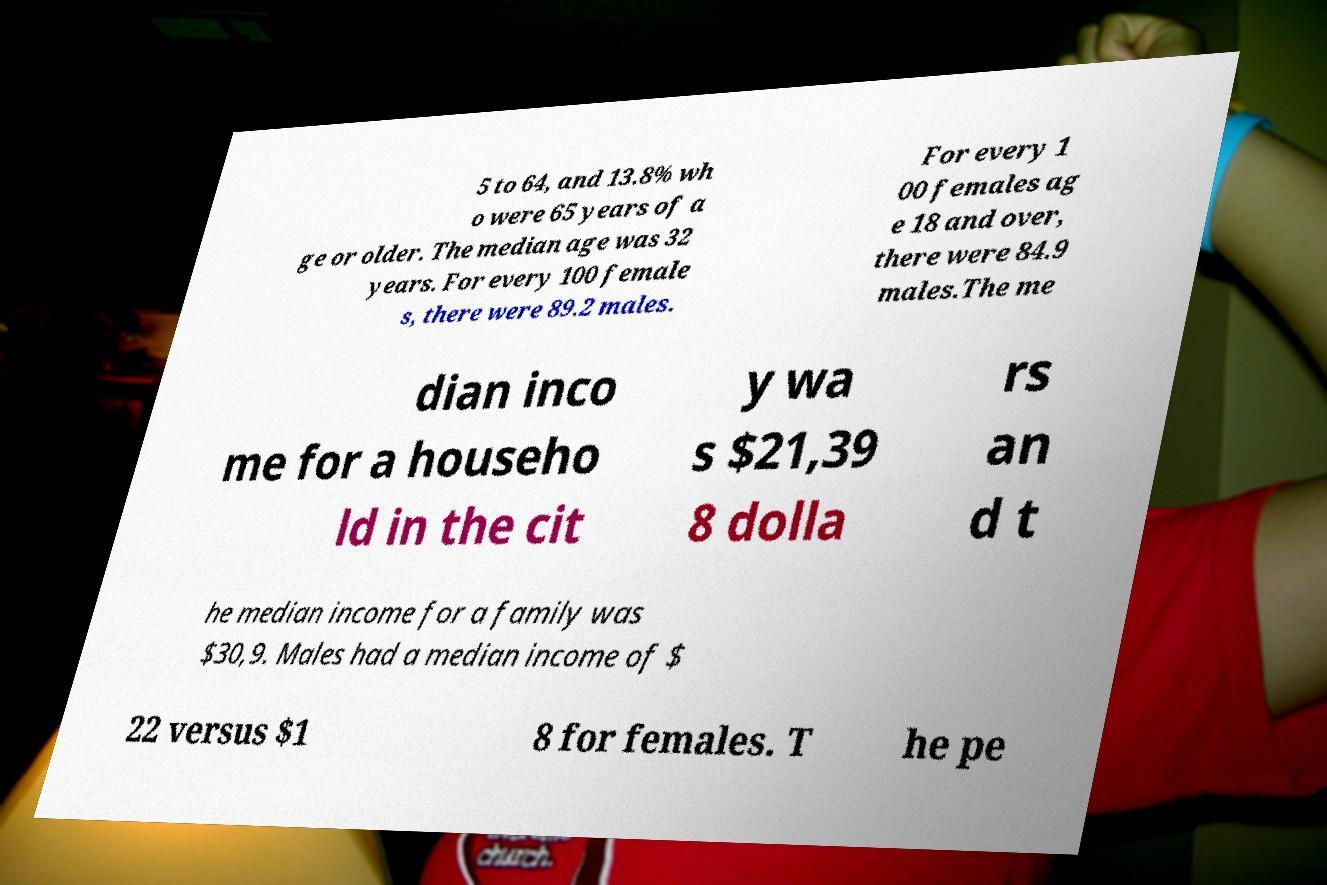I need the written content from this picture converted into text. Can you do that? 5 to 64, and 13.8% wh o were 65 years of a ge or older. The median age was 32 years. For every 100 female s, there were 89.2 males. For every 1 00 females ag e 18 and over, there were 84.9 males.The me dian inco me for a househo ld in the cit y wa s $21,39 8 dolla rs an d t he median income for a family was $30,9. Males had a median income of $ 22 versus $1 8 for females. T he pe 